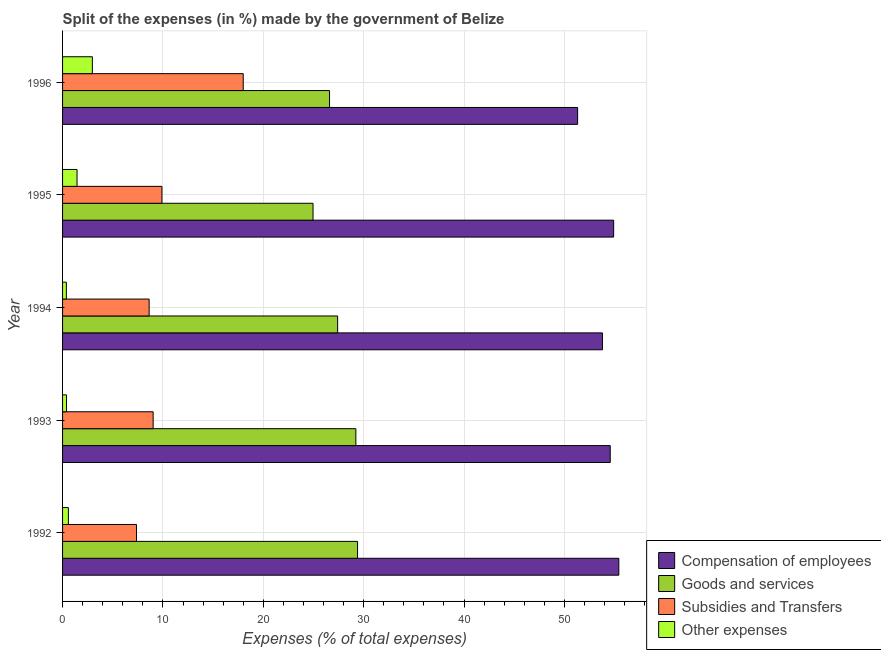How many groups of bars are there?
Your answer should be compact. 5. Are the number of bars per tick equal to the number of legend labels?
Offer a terse response. Yes. How many bars are there on the 1st tick from the top?
Ensure brevity in your answer.  4. In how many cases, is the number of bars for a given year not equal to the number of legend labels?
Keep it short and to the point. 0. What is the percentage of amount spent on other expenses in 1992?
Your response must be concise. 0.58. Across all years, what is the maximum percentage of amount spent on subsidies?
Your answer should be compact. 18. Across all years, what is the minimum percentage of amount spent on subsidies?
Offer a terse response. 7.37. In which year was the percentage of amount spent on goods and services maximum?
Make the answer very short. 1992. What is the total percentage of amount spent on subsidies in the graph?
Ensure brevity in your answer.  52.92. What is the difference between the percentage of amount spent on compensation of employees in 1995 and that in 1996?
Make the answer very short. 3.59. What is the difference between the percentage of amount spent on goods and services in 1993 and the percentage of amount spent on other expenses in 1996?
Your answer should be very brief. 26.25. What is the average percentage of amount spent on other expenses per year?
Ensure brevity in your answer.  1.15. In the year 1995, what is the difference between the percentage of amount spent on subsidies and percentage of amount spent on other expenses?
Your answer should be very brief. 8.46. In how many years, is the percentage of amount spent on subsidies greater than 12 %?
Offer a terse response. 1. What is the ratio of the percentage of amount spent on subsidies in 1994 to that in 1995?
Offer a very short reply. 0.87. Is the difference between the percentage of amount spent on subsidies in 1995 and 1996 greater than the difference between the percentage of amount spent on goods and services in 1995 and 1996?
Give a very brief answer. No. What is the difference between the highest and the second highest percentage of amount spent on subsidies?
Provide a succinct answer. 8.1. What is the difference between the highest and the lowest percentage of amount spent on goods and services?
Give a very brief answer. 4.44. In how many years, is the percentage of amount spent on subsidies greater than the average percentage of amount spent on subsidies taken over all years?
Offer a terse response. 1. Is the sum of the percentage of amount spent on other expenses in 1992 and 1995 greater than the maximum percentage of amount spent on compensation of employees across all years?
Keep it short and to the point. No. What does the 1st bar from the top in 1992 represents?
Provide a short and direct response. Other expenses. What does the 1st bar from the bottom in 1994 represents?
Keep it short and to the point. Compensation of employees. Are all the bars in the graph horizontal?
Provide a succinct answer. Yes. What is the difference between two consecutive major ticks on the X-axis?
Provide a short and direct response. 10. How many legend labels are there?
Provide a succinct answer. 4. How are the legend labels stacked?
Offer a very short reply. Vertical. What is the title of the graph?
Provide a short and direct response. Split of the expenses (in %) made by the government of Belize. Does "Others" appear as one of the legend labels in the graph?
Offer a terse response. No. What is the label or title of the X-axis?
Your answer should be very brief. Expenses (% of total expenses). What is the Expenses (% of total expenses) in Compensation of employees in 1992?
Provide a succinct answer. 55.42. What is the Expenses (% of total expenses) in Goods and services in 1992?
Keep it short and to the point. 29.39. What is the Expenses (% of total expenses) of Subsidies and Transfers in 1992?
Make the answer very short. 7.37. What is the Expenses (% of total expenses) of Other expenses in 1992?
Your answer should be very brief. 0.58. What is the Expenses (% of total expenses) in Compensation of employees in 1993?
Keep it short and to the point. 54.57. What is the Expenses (% of total expenses) in Goods and services in 1993?
Ensure brevity in your answer.  29.22. What is the Expenses (% of total expenses) of Subsidies and Transfers in 1993?
Keep it short and to the point. 9.02. What is the Expenses (% of total expenses) in Other expenses in 1993?
Your response must be concise. 0.39. What is the Expenses (% of total expenses) of Compensation of employees in 1994?
Your answer should be very brief. 53.79. What is the Expenses (% of total expenses) in Goods and services in 1994?
Offer a terse response. 27.41. What is the Expenses (% of total expenses) in Subsidies and Transfers in 1994?
Keep it short and to the point. 8.63. What is the Expenses (% of total expenses) of Other expenses in 1994?
Keep it short and to the point. 0.38. What is the Expenses (% of total expenses) in Compensation of employees in 1995?
Keep it short and to the point. 54.91. What is the Expenses (% of total expenses) in Goods and services in 1995?
Provide a succinct answer. 24.95. What is the Expenses (% of total expenses) in Subsidies and Transfers in 1995?
Provide a short and direct response. 9.9. What is the Expenses (% of total expenses) of Other expenses in 1995?
Your answer should be very brief. 1.44. What is the Expenses (% of total expenses) in Compensation of employees in 1996?
Make the answer very short. 51.32. What is the Expenses (% of total expenses) in Goods and services in 1996?
Provide a short and direct response. 26.6. What is the Expenses (% of total expenses) of Subsidies and Transfers in 1996?
Your response must be concise. 18. What is the Expenses (% of total expenses) in Other expenses in 1996?
Offer a terse response. 2.97. Across all years, what is the maximum Expenses (% of total expenses) in Compensation of employees?
Ensure brevity in your answer.  55.42. Across all years, what is the maximum Expenses (% of total expenses) of Goods and services?
Offer a very short reply. 29.39. Across all years, what is the maximum Expenses (% of total expenses) in Subsidies and Transfers?
Your answer should be very brief. 18. Across all years, what is the maximum Expenses (% of total expenses) of Other expenses?
Keep it short and to the point. 2.97. Across all years, what is the minimum Expenses (% of total expenses) in Compensation of employees?
Offer a terse response. 51.32. Across all years, what is the minimum Expenses (% of total expenses) in Goods and services?
Your answer should be very brief. 24.95. Across all years, what is the minimum Expenses (% of total expenses) of Subsidies and Transfers?
Provide a succinct answer. 7.37. Across all years, what is the minimum Expenses (% of total expenses) of Other expenses?
Make the answer very short. 0.38. What is the total Expenses (% of total expenses) in Compensation of employees in the graph?
Provide a short and direct response. 270. What is the total Expenses (% of total expenses) in Goods and services in the graph?
Your answer should be compact. 137.57. What is the total Expenses (% of total expenses) of Subsidies and Transfers in the graph?
Your answer should be very brief. 52.92. What is the total Expenses (% of total expenses) of Other expenses in the graph?
Offer a terse response. 5.76. What is the difference between the Expenses (% of total expenses) in Compensation of employees in 1992 and that in 1993?
Make the answer very short. 0.86. What is the difference between the Expenses (% of total expenses) of Goods and services in 1992 and that in 1993?
Ensure brevity in your answer.  0.17. What is the difference between the Expenses (% of total expenses) in Subsidies and Transfers in 1992 and that in 1993?
Offer a terse response. -1.66. What is the difference between the Expenses (% of total expenses) of Other expenses in 1992 and that in 1993?
Provide a succinct answer. 0.19. What is the difference between the Expenses (% of total expenses) in Compensation of employees in 1992 and that in 1994?
Make the answer very short. 1.63. What is the difference between the Expenses (% of total expenses) of Goods and services in 1992 and that in 1994?
Give a very brief answer. 1.99. What is the difference between the Expenses (% of total expenses) of Subsidies and Transfers in 1992 and that in 1994?
Make the answer very short. -1.26. What is the difference between the Expenses (% of total expenses) of Other expenses in 1992 and that in 1994?
Offer a very short reply. 0.2. What is the difference between the Expenses (% of total expenses) in Compensation of employees in 1992 and that in 1995?
Keep it short and to the point. 0.52. What is the difference between the Expenses (% of total expenses) in Goods and services in 1992 and that in 1995?
Ensure brevity in your answer.  4.44. What is the difference between the Expenses (% of total expenses) of Subsidies and Transfers in 1992 and that in 1995?
Your answer should be very brief. -2.53. What is the difference between the Expenses (% of total expenses) of Other expenses in 1992 and that in 1995?
Your answer should be compact. -0.86. What is the difference between the Expenses (% of total expenses) of Compensation of employees in 1992 and that in 1996?
Your answer should be compact. 4.11. What is the difference between the Expenses (% of total expenses) of Goods and services in 1992 and that in 1996?
Provide a short and direct response. 2.79. What is the difference between the Expenses (% of total expenses) in Subsidies and Transfers in 1992 and that in 1996?
Give a very brief answer. -10.63. What is the difference between the Expenses (% of total expenses) in Other expenses in 1992 and that in 1996?
Give a very brief answer. -2.39. What is the difference between the Expenses (% of total expenses) in Compensation of employees in 1993 and that in 1994?
Provide a short and direct response. 0.78. What is the difference between the Expenses (% of total expenses) of Goods and services in 1993 and that in 1994?
Provide a succinct answer. 1.82. What is the difference between the Expenses (% of total expenses) of Subsidies and Transfers in 1993 and that in 1994?
Your answer should be very brief. 0.4. What is the difference between the Expenses (% of total expenses) of Other expenses in 1993 and that in 1994?
Offer a very short reply. 0.02. What is the difference between the Expenses (% of total expenses) in Compensation of employees in 1993 and that in 1995?
Give a very brief answer. -0.34. What is the difference between the Expenses (% of total expenses) of Goods and services in 1993 and that in 1995?
Your answer should be compact. 4.27. What is the difference between the Expenses (% of total expenses) in Subsidies and Transfers in 1993 and that in 1995?
Provide a succinct answer. -0.88. What is the difference between the Expenses (% of total expenses) of Other expenses in 1993 and that in 1995?
Your response must be concise. -1.05. What is the difference between the Expenses (% of total expenses) of Compensation of employees in 1993 and that in 1996?
Ensure brevity in your answer.  3.25. What is the difference between the Expenses (% of total expenses) of Goods and services in 1993 and that in 1996?
Provide a succinct answer. 2.62. What is the difference between the Expenses (% of total expenses) of Subsidies and Transfers in 1993 and that in 1996?
Your answer should be very brief. -8.97. What is the difference between the Expenses (% of total expenses) in Other expenses in 1993 and that in 1996?
Provide a short and direct response. -2.57. What is the difference between the Expenses (% of total expenses) in Compensation of employees in 1994 and that in 1995?
Keep it short and to the point. -1.12. What is the difference between the Expenses (% of total expenses) of Goods and services in 1994 and that in 1995?
Your answer should be very brief. 2.45. What is the difference between the Expenses (% of total expenses) of Subsidies and Transfers in 1994 and that in 1995?
Offer a terse response. -1.28. What is the difference between the Expenses (% of total expenses) of Other expenses in 1994 and that in 1995?
Provide a short and direct response. -1.06. What is the difference between the Expenses (% of total expenses) of Compensation of employees in 1994 and that in 1996?
Make the answer very short. 2.47. What is the difference between the Expenses (% of total expenses) of Goods and services in 1994 and that in 1996?
Ensure brevity in your answer.  0.81. What is the difference between the Expenses (% of total expenses) in Subsidies and Transfers in 1994 and that in 1996?
Your answer should be very brief. -9.37. What is the difference between the Expenses (% of total expenses) in Other expenses in 1994 and that in 1996?
Provide a succinct answer. -2.59. What is the difference between the Expenses (% of total expenses) in Compensation of employees in 1995 and that in 1996?
Offer a very short reply. 3.59. What is the difference between the Expenses (% of total expenses) of Goods and services in 1995 and that in 1996?
Your response must be concise. -1.65. What is the difference between the Expenses (% of total expenses) in Subsidies and Transfers in 1995 and that in 1996?
Make the answer very short. -8.1. What is the difference between the Expenses (% of total expenses) in Other expenses in 1995 and that in 1996?
Give a very brief answer. -1.53. What is the difference between the Expenses (% of total expenses) of Compensation of employees in 1992 and the Expenses (% of total expenses) of Goods and services in 1993?
Keep it short and to the point. 26.2. What is the difference between the Expenses (% of total expenses) in Compensation of employees in 1992 and the Expenses (% of total expenses) in Subsidies and Transfers in 1993?
Offer a terse response. 46.4. What is the difference between the Expenses (% of total expenses) in Compensation of employees in 1992 and the Expenses (% of total expenses) in Other expenses in 1993?
Offer a terse response. 55.03. What is the difference between the Expenses (% of total expenses) in Goods and services in 1992 and the Expenses (% of total expenses) in Subsidies and Transfers in 1993?
Your answer should be very brief. 20.37. What is the difference between the Expenses (% of total expenses) in Goods and services in 1992 and the Expenses (% of total expenses) in Other expenses in 1993?
Offer a very short reply. 29. What is the difference between the Expenses (% of total expenses) of Subsidies and Transfers in 1992 and the Expenses (% of total expenses) of Other expenses in 1993?
Provide a succinct answer. 6.97. What is the difference between the Expenses (% of total expenses) in Compensation of employees in 1992 and the Expenses (% of total expenses) in Goods and services in 1994?
Provide a succinct answer. 28.02. What is the difference between the Expenses (% of total expenses) in Compensation of employees in 1992 and the Expenses (% of total expenses) in Subsidies and Transfers in 1994?
Make the answer very short. 46.8. What is the difference between the Expenses (% of total expenses) in Compensation of employees in 1992 and the Expenses (% of total expenses) in Other expenses in 1994?
Your answer should be compact. 55.04. What is the difference between the Expenses (% of total expenses) in Goods and services in 1992 and the Expenses (% of total expenses) in Subsidies and Transfers in 1994?
Offer a terse response. 20.77. What is the difference between the Expenses (% of total expenses) in Goods and services in 1992 and the Expenses (% of total expenses) in Other expenses in 1994?
Offer a terse response. 29.01. What is the difference between the Expenses (% of total expenses) in Subsidies and Transfers in 1992 and the Expenses (% of total expenses) in Other expenses in 1994?
Provide a short and direct response. 6.99. What is the difference between the Expenses (% of total expenses) of Compensation of employees in 1992 and the Expenses (% of total expenses) of Goods and services in 1995?
Offer a very short reply. 30.47. What is the difference between the Expenses (% of total expenses) in Compensation of employees in 1992 and the Expenses (% of total expenses) in Subsidies and Transfers in 1995?
Offer a terse response. 45.52. What is the difference between the Expenses (% of total expenses) of Compensation of employees in 1992 and the Expenses (% of total expenses) of Other expenses in 1995?
Give a very brief answer. 53.98. What is the difference between the Expenses (% of total expenses) in Goods and services in 1992 and the Expenses (% of total expenses) in Subsidies and Transfers in 1995?
Ensure brevity in your answer.  19.49. What is the difference between the Expenses (% of total expenses) of Goods and services in 1992 and the Expenses (% of total expenses) of Other expenses in 1995?
Your answer should be compact. 27.95. What is the difference between the Expenses (% of total expenses) of Subsidies and Transfers in 1992 and the Expenses (% of total expenses) of Other expenses in 1995?
Ensure brevity in your answer.  5.93. What is the difference between the Expenses (% of total expenses) in Compensation of employees in 1992 and the Expenses (% of total expenses) in Goods and services in 1996?
Make the answer very short. 28.82. What is the difference between the Expenses (% of total expenses) in Compensation of employees in 1992 and the Expenses (% of total expenses) in Subsidies and Transfers in 1996?
Provide a succinct answer. 37.42. What is the difference between the Expenses (% of total expenses) in Compensation of employees in 1992 and the Expenses (% of total expenses) in Other expenses in 1996?
Your answer should be very brief. 52.45. What is the difference between the Expenses (% of total expenses) in Goods and services in 1992 and the Expenses (% of total expenses) in Subsidies and Transfers in 1996?
Your answer should be very brief. 11.39. What is the difference between the Expenses (% of total expenses) in Goods and services in 1992 and the Expenses (% of total expenses) in Other expenses in 1996?
Your answer should be very brief. 26.42. What is the difference between the Expenses (% of total expenses) in Subsidies and Transfers in 1992 and the Expenses (% of total expenses) in Other expenses in 1996?
Provide a short and direct response. 4.4. What is the difference between the Expenses (% of total expenses) of Compensation of employees in 1993 and the Expenses (% of total expenses) of Goods and services in 1994?
Your answer should be compact. 27.16. What is the difference between the Expenses (% of total expenses) of Compensation of employees in 1993 and the Expenses (% of total expenses) of Subsidies and Transfers in 1994?
Your answer should be compact. 45.94. What is the difference between the Expenses (% of total expenses) of Compensation of employees in 1993 and the Expenses (% of total expenses) of Other expenses in 1994?
Your answer should be very brief. 54.19. What is the difference between the Expenses (% of total expenses) of Goods and services in 1993 and the Expenses (% of total expenses) of Subsidies and Transfers in 1994?
Provide a short and direct response. 20.6. What is the difference between the Expenses (% of total expenses) of Goods and services in 1993 and the Expenses (% of total expenses) of Other expenses in 1994?
Your response must be concise. 28.84. What is the difference between the Expenses (% of total expenses) in Subsidies and Transfers in 1993 and the Expenses (% of total expenses) in Other expenses in 1994?
Your answer should be very brief. 8.65. What is the difference between the Expenses (% of total expenses) of Compensation of employees in 1993 and the Expenses (% of total expenses) of Goods and services in 1995?
Give a very brief answer. 29.61. What is the difference between the Expenses (% of total expenses) in Compensation of employees in 1993 and the Expenses (% of total expenses) in Subsidies and Transfers in 1995?
Offer a very short reply. 44.66. What is the difference between the Expenses (% of total expenses) in Compensation of employees in 1993 and the Expenses (% of total expenses) in Other expenses in 1995?
Your answer should be very brief. 53.12. What is the difference between the Expenses (% of total expenses) in Goods and services in 1993 and the Expenses (% of total expenses) in Subsidies and Transfers in 1995?
Offer a very short reply. 19.32. What is the difference between the Expenses (% of total expenses) in Goods and services in 1993 and the Expenses (% of total expenses) in Other expenses in 1995?
Provide a short and direct response. 27.78. What is the difference between the Expenses (% of total expenses) of Subsidies and Transfers in 1993 and the Expenses (% of total expenses) of Other expenses in 1995?
Give a very brief answer. 7.58. What is the difference between the Expenses (% of total expenses) of Compensation of employees in 1993 and the Expenses (% of total expenses) of Goods and services in 1996?
Make the answer very short. 27.96. What is the difference between the Expenses (% of total expenses) in Compensation of employees in 1993 and the Expenses (% of total expenses) in Subsidies and Transfers in 1996?
Offer a very short reply. 36.57. What is the difference between the Expenses (% of total expenses) in Compensation of employees in 1993 and the Expenses (% of total expenses) in Other expenses in 1996?
Ensure brevity in your answer.  51.6. What is the difference between the Expenses (% of total expenses) in Goods and services in 1993 and the Expenses (% of total expenses) in Subsidies and Transfers in 1996?
Your answer should be compact. 11.22. What is the difference between the Expenses (% of total expenses) of Goods and services in 1993 and the Expenses (% of total expenses) of Other expenses in 1996?
Provide a succinct answer. 26.25. What is the difference between the Expenses (% of total expenses) of Subsidies and Transfers in 1993 and the Expenses (% of total expenses) of Other expenses in 1996?
Your response must be concise. 6.06. What is the difference between the Expenses (% of total expenses) of Compensation of employees in 1994 and the Expenses (% of total expenses) of Goods and services in 1995?
Provide a short and direct response. 28.83. What is the difference between the Expenses (% of total expenses) of Compensation of employees in 1994 and the Expenses (% of total expenses) of Subsidies and Transfers in 1995?
Offer a terse response. 43.89. What is the difference between the Expenses (% of total expenses) of Compensation of employees in 1994 and the Expenses (% of total expenses) of Other expenses in 1995?
Give a very brief answer. 52.35. What is the difference between the Expenses (% of total expenses) of Goods and services in 1994 and the Expenses (% of total expenses) of Subsidies and Transfers in 1995?
Give a very brief answer. 17.5. What is the difference between the Expenses (% of total expenses) of Goods and services in 1994 and the Expenses (% of total expenses) of Other expenses in 1995?
Your response must be concise. 25.96. What is the difference between the Expenses (% of total expenses) in Subsidies and Transfers in 1994 and the Expenses (% of total expenses) in Other expenses in 1995?
Your answer should be very brief. 7.18. What is the difference between the Expenses (% of total expenses) in Compensation of employees in 1994 and the Expenses (% of total expenses) in Goods and services in 1996?
Make the answer very short. 27.19. What is the difference between the Expenses (% of total expenses) in Compensation of employees in 1994 and the Expenses (% of total expenses) in Subsidies and Transfers in 1996?
Provide a short and direct response. 35.79. What is the difference between the Expenses (% of total expenses) of Compensation of employees in 1994 and the Expenses (% of total expenses) of Other expenses in 1996?
Your answer should be compact. 50.82. What is the difference between the Expenses (% of total expenses) in Goods and services in 1994 and the Expenses (% of total expenses) in Subsidies and Transfers in 1996?
Keep it short and to the point. 9.41. What is the difference between the Expenses (% of total expenses) of Goods and services in 1994 and the Expenses (% of total expenses) of Other expenses in 1996?
Your response must be concise. 24.44. What is the difference between the Expenses (% of total expenses) of Subsidies and Transfers in 1994 and the Expenses (% of total expenses) of Other expenses in 1996?
Provide a succinct answer. 5.66. What is the difference between the Expenses (% of total expenses) of Compensation of employees in 1995 and the Expenses (% of total expenses) of Goods and services in 1996?
Your answer should be very brief. 28.31. What is the difference between the Expenses (% of total expenses) of Compensation of employees in 1995 and the Expenses (% of total expenses) of Subsidies and Transfers in 1996?
Keep it short and to the point. 36.91. What is the difference between the Expenses (% of total expenses) in Compensation of employees in 1995 and the Expenses (% of total expenses) in Other expenses in 1996?
Your response must be concise. 51.94. What is the difference between the Expenses (% of total expenses) in Goods and services in 1995 and the Expenses (% of total expenses) in Subsidies and Transfers in 1996?
Provide a short and direct response. 6.96. What is the difference between the Expenses (% of total expenses) in Goods and services in 1995 and the Expenses (% of total expenses) in Other expenses in 1996?
Provide a short and direct response. 21.99. What is the difference between the Expenses (% of total expenses) of Subsidies and Transfers in 1995 and the Expenses (% of total expenses) of Other expenses in 1996?
Keep it short and to the point. 6.93. What is the average Expenses (% of total expenses) of Compensation of employees per year?
Ensure brevity in your answer.  54. What is the average Expenses (% of total expenses) in Goods and services per year?
Provide a short and direct response. 27.51. What is the average Expenses (% of total expenses) in Subsidies and Transfers per year?
Ensure brevity in your answer.  10.58. What is the average Expenses (% of total expenses) of Other expenses per year?
Keep it short and to the point. 1.15. In the year 1992, what is the difference between the Expenses (% of total expenses) of Compensation of employees and Expenses (% of total expenses) of Goods and services?
Offer a very short reply. 26.03. In the year 1992, what is the difference between the Expenses (% of total expenses) of Compensation of employees and Expenses (% of total expenses) of Subsidies and Transfers?
Give a very brief answer. 48.05. In the year 1992, what is the difference between the Expenses (% of total expenses) of Compensation of employees and Expenses (% of total expenses) of Other expenses?
Give a very brief answer. 54.84. In the year 1992, what is the difference between the Expenses (% of total expenses) of Goods and services and Expenses (% of total expenses) of Subsidies and Transfers?
Your answer should be compact. 22.02. In the year 1992, what is the difference between the Expenses (% of total expenses) of Goods and services and Expenses (% of total expenses) of Other expenses?
Ensure brevity in your answer.  28.81. In the year 1992, what is the difference between the Expenses (% of total expenses) of Subsidies and Transfers and Expenses (% of total expenses) of Other expenses?
Ensure brevity in your answer.  6.79. In the year 1993, what is the difference between the Expenses (% of total expenses) of Compensation of employees and Expenses (% of total expenses) of Goods and services?
Provide a succinct answer. 25.34. In the year 1993, what is the difference between the Expenses (% of total expenses) in Compensation of employees and Expenses (% of total expenses) in Subsidies and Transfers?
Offer a very short reply. 45.54. In the year 1993, what is the difference between the Expenses (% of total expenses) of Compensation of employees and Expenses (% of total expenses) of Other expenses?
Your answer should be compact. 54.17. In the year 1993, what is the difference between the Expenses (% of total expenses) in Goods and services and Expenses (% of total expenses) in Subsidies and Transfers?
Keep it short and to the point. 20.2. In the year 1993, what is the difference between the Expenses (% of total expenses) of Goods and services and Expenses (% of total expenses) of Other expenses?
Keep it short and to the point. 28.83. In the year 1993, what is the difference between the Expenses (% of total expenses) of Subsidies and Transfers and Expenses (% of total expenses) of Other expenses?
Make the answer very short. 8.63. In the year 1994, what is the difference between the Expenses (% of total expenses) of Compensation of employees and Expenses (% of total expenses) of Goods and services?
Offer a terse response. 26.38. In the year 1994, what is the difference between the Expenses (% of total expenses) in Compensation of employees and Expenses (% of total expenses) in Subsidies and Transfers?
Make the answer very short. 45.16. In the year 1994, what is the difference between the Expenses (% of total expenses) of Compensation of employees and Expenses (% of total expenses) of Other expenses?
Offer a terse response. 53.41. In the year 1994, what is the difference between the Expenses (% of total expenses) in Goods and services and Expenses (% of total expenses) in Subsidies and Transfers?
Your answer should be very brief. 18.78. In the year 1994, what is the difference between the Expenses (% of total expenses) of Goods and services and Expenses (% of total expenses) of Other expenses?
Ensure brevity in your answer.  27.03. In the year 1994, what is the difference between the Expenses (% of total expenses) in Subsidies and Transfers and Expenses (% of total expenses) in Other expenses?
Give a very brief answer. 8.25. In the year 1995, what is the difference between the Expenses (% of total expenses) of Compensation of employees and Expenses (% of total expenses) of Goods and services?
Make the answer very short. 29.95. In the year 1995, what is the difference between the Expenses (% of total expenses) in Compensation of employees and Expenses (% of total expenses) in Subsidies and Transfers?
Provide a short and direct response. 45.01. In the year 1995, what is the difference between the Expenses (% of total expenses) in Compensation of employees and Expenses (% of total expenses) in Other expenses?
Your answer should be very brief. 53.47. In the year 1995, what is the difference between the Expenses (% of total expenses) in Goods and services and Expenses (% of total expenses) in Subsidies and Transfers?
Provide a succinct answer. 15.05. In the year 1995, what is the difference between the Expenses (% of total expenses) in Goods and services and Expenses (% of total expenses) in Other expenses?
Make the answer very short. 23.51. In the year 1995, what is the difference between the Expenses (% of total expenses) in Subsidies and Transfers and Expenses (% of total expenses) in Other expenses?
Ensure brevity in your answer.  8.46. In the year 1996, what is the difference between the Expenses (% of total expenses) of Compensation of employees and Expenses (% of total expenses) of Goods and services?
Ensure brevity in your answer.  24.72. In the year 1996, what is the difference between the Expenses (% of total expenses) of Compensation of employees and Expenses (% of total expenses) of Subsidies and Transfers?
Your answer should be compact. 33.32. In the year 1996, what is the difference between the Expenses (% of total expenses) in Compensation of employees and Expenses (% of total expenses) in Other expenses?
Your answer should be compact. 48.35. In the year 1996, what is the difference between the Expenses (% of total expenses) in Goods and services and Expenses (% of total expenses) in Subsidies and Transfers?
Offer a terse response. 8.6. In the year 1996, what is the difference between the Expenses (% of total expenses) in Goods and services and Expenses (% of total expenses) in Other expenses?
Your response must be concise. 23.63. In the year 1996, what is the difference between the Expenses (% of total expenses) of Subsidies and Transfers and Expenses (% of total expenses) of Other expenses?
Offer a terse response. 15.03. What is the ratio of the Expenses (% of total expenses) in Compensation of employees in 1992 to that in 1993?
Your answer should be very brief. 1.02. What is the ratio of the Expenses (% of total expenses) in Subsidies and Transfers in 1992 to that in 1993?
Make the answer very short. 0.82. What is the ratio of the Expenses (% of total expenses) of Other expenses in 1992 to that in 1993?
Offer a very short reply. 1.48. What is the ratio of the Expenses (% of total expenses) in Compensation of employees in 1992 to that in 1994?
Offer a very short reply. 1.03. What is the ratio of the Expenses (% of total expenses) of Goods and services in 1992 to that in 1994?
Your answer should be very brief. 1.07. What is the ratio of the Expenses (% of total expenses) in Subsidies and Transfers in 1992 to that in 1994?
Make the answer very short. 0.85. What is the ratio of the Expenses (% of total expenses) in Other expenses in 1992 to that in 1994?
Keep it short and to the point. 1.54. What is the ratio of the Expenses (% of total expenses) in Compensation of employees in 1992 to that in 1995?
Make the answer very short. 1.01. What is the ratio of the Expenses (% of total expenses) in Goods and services in 1992 to that in 1995?
Your answer should be very brief. 1.18. What is the ratio of the Expenses (% of total expenses) of Subsidies and Transfers in 1992 to that in 1995?
Offer a terse response. 0.74. What is the ratio of the Expenses (% of total expenses) of Other expenses in 1992 to that in 1995?
Ensure brevity in your answer.  0.4. What is the ratio of the Expenses (% of total expenses) of Goods and services in 1992 to that in 1996?
Offer a very short reply. 1.1. What is the ratio of the Expenses (% of total expenses) in Subsidies and Transfers in 1992 to that in 1996?
Make the answer very short. 0.41. What is the ratio of the Expenses (% of total expenses) in Other expenses in 1992 to that in 1996?
Make the answer very short. 0.2. What is the ratio of the Expenses (% of total expenses) of Compensation of employees in 1993 to that in 1994?
Ensure brevity in your answer.  1.01. What is the ratio of the Expenses (% of total expenses) in Goods and services in 1993 to that in 1994?
Provide a short and direct response. 1.07. What is the ratio of the Expenses (% of total expenses) of Subsidies and Transfers in 1993 to that in 1994?
Your response must be concise. 1.05. What is the ratio of the Expenses (% of total expenses) in Other expenses in 1993 to that in 1994?
Provide a succinct answer. 1.04. What is the ratio of the Expenses (% of total expenses) in Goods and services in 1993 to that in 1995?
Provide a short and direct response. 1.17. What is the ratio of the Expenses (% of total expenses) of Subsidies and Transfers in 1993 to that in 1995?
Provide a succinct answer. 0.91. What is the ratio of the Expenses (% of total expenses) in Other expenses in 1993 to that in 1995?
Your answer should be very brief. 0.27. What is the ratio of the Expenses (% of total expenses) in Compensation of employees in 1993 to that in 1996?
Your answer should be very brief. 1.06. What is the ratio of the Expenses (% of total expenses) of Goods and services in 1993 to that in 1996?
Offer a terse response. 1.1. What is the ratio of the Expenses (% of total expenses) in Subsidies and Transfers in 1993 to that in 1996?
Your answer should be very brief. 0.5. What is the ratio of the Expenses (% of total expenses) of Other expenses in 1993 to that in 1996?
Offer a terse response. 0.13. What is the ratio of the Expenses (% of total expenses) of Compensation of employees in 1994 to that in 1995?
Provide a short and direct response. 0.98. What is the ratio of the Expenses (% of total expenses) of Goods and services in 1994 to that in 1995?
Provide a succinct answer. 1.1. What is the ratio of the Expenses (% of total expenses) in Subsidies and Transfers in 1994 to that in 1995?
Give a very brief answer. 0.87. What is the ratio of the Expenses (% of total expenses) of Other expenses in 1994 to that in 1995?
Your answer should be very brief. 0.26. What is the ratio of the Expenses (% of total expenses) in Compensation of employees in 1994 to that in 1996?
Offer a terse response. 1.05. What is the ratio of the Expenses (% of total expenses) of Goods and services in 1994 to that in 1996?
Offer a very short reply. 1.03. What is the ratio of the Expenses (% of total expenses) in Subsidies and Transfers in 1994 to that in 1996?
Offer a terse response. 0.48. What is the ratio of the Expenses (% of total expenses) in Other expenses in 1994 to that in 1996?
Give a very brief answer. 0.13. What is the ratio of the Expenses (% of total expenses) of Compensation of employees in 1995 to that in 1996?
Make the answer very short. 1.07. What is the ratio of the Expenses (% of total expenses) in Goods and services in 1995 to that in 1996?
Ensure brevity in your answer.  0.94. What is the ratio of the Expenses (% of total expenses) of Subsidies and Transfers in 1995 to that in 1996?
Keep it short and to the point. 0.55. What is the ratio of the Expenses (% of total expenses) of Other expenses in 1995 to that in 1996?
Offer a very short reply. 0.49. What is the difference between the highest and the second highest Expenses (% of total expenses) of Compensation of employees?
Offer a terse response. 0.52. What is the difference between the highest and the second highest Expenses (% of total expenses) in Goods and services?
Give a very brief answer. 0.17. What is the difference between the highest and the second highest Expenses (% of total expenses) of Subsidies and Transfers?
Offer a very short reply. 8.1. What is the difference between the highest and the second highest Expenses (% of total expenses) in Other expenses?
Your answer should be compact. 1.53. What is the difference between the highest and the lowest Expenses (% of total expenses) of Compensation of employees?
Your answer should be very brief. 4.11. What is the difference between the highest and the lowest Expenses (% of total expenses) in Goods and services?
Provide a succinct answer. 4.44. What is the difference between the highest and the lowest Expenses (% of total expenses) in Subsidies and Transfers?
Your answer should be very brief. 10.63. What is the difference between the highest and the lowest Expenses (% of total expenses) in Other expenses?
Offer a very short reply. 2.59. 